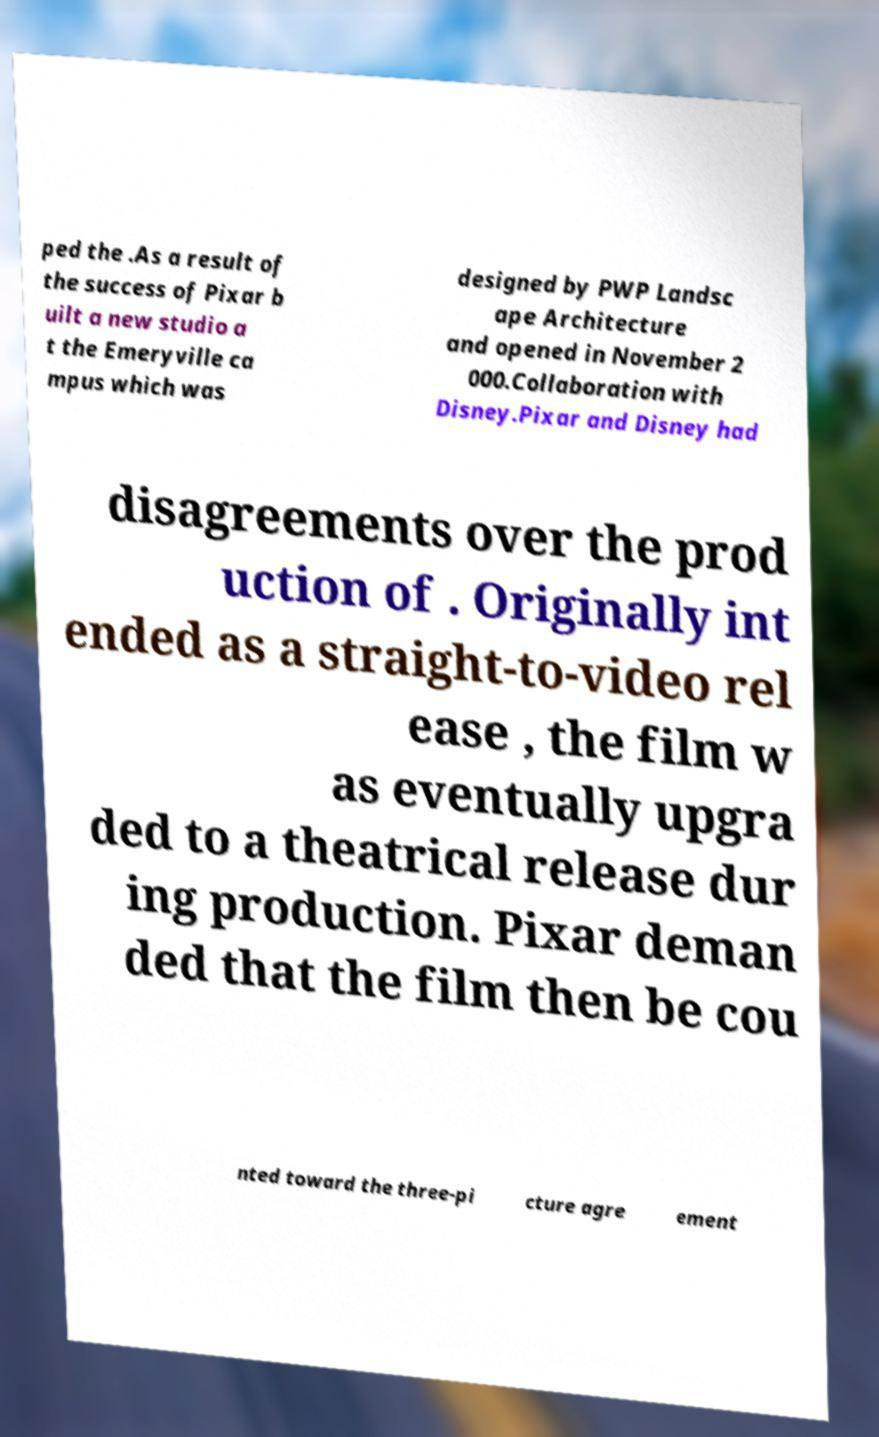I need the written content from this picture converted into text. Can you do that? ped the .As a result of the success of Pixar b uilt a new studio a t the Emeryville ca mpus which was designed by PWP Landsc ape Architecture and opened in November 2 000.Collaboration with Disney.Pixar and Disney had disagreements over the prod uction of . Originally int ended as a straight-to-video rel ease , the film w as eventually upgra ded to a theatrical release dur ing production. Pixar deman ded that the film then be cou nted toward the three-pi cture agre ement 